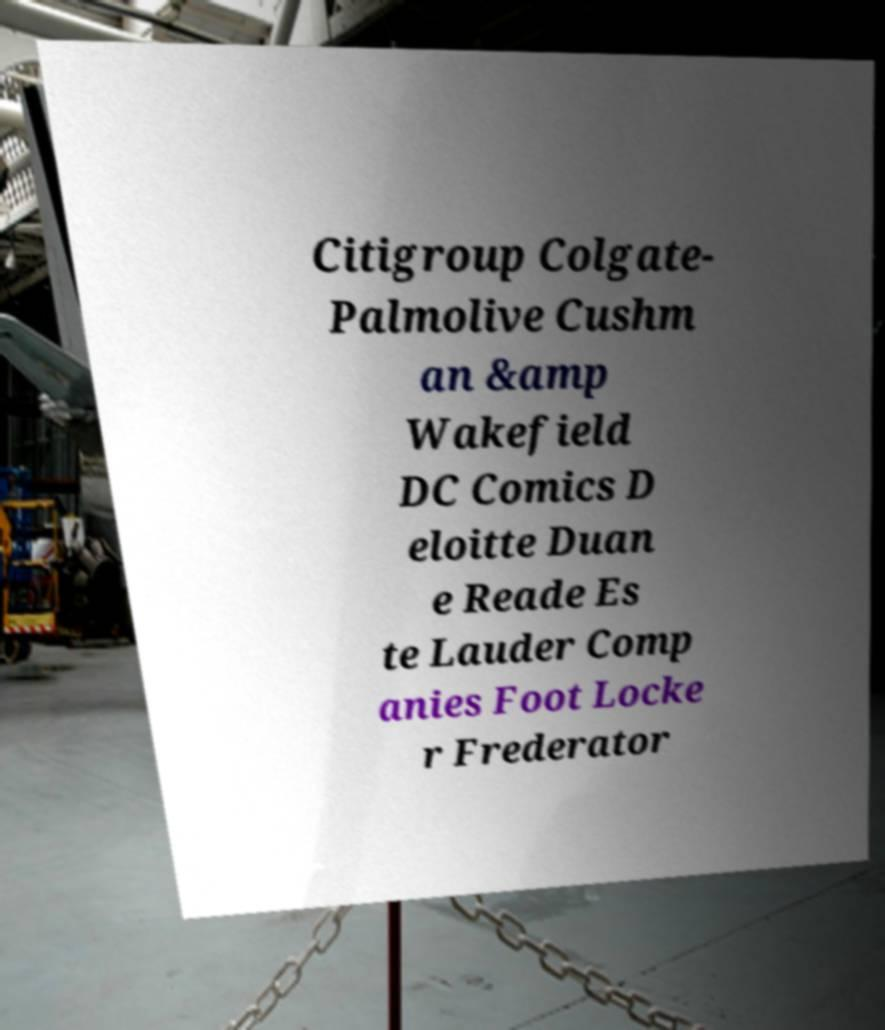Can you accurately transcribe the text from the provided image for me? Citigroup Colgate- Palmolive Cushm an &amp Wakefield DC Comics D eloitte Duan e Reade Es te Lauder Comp anies Foot Locke r Frederator 